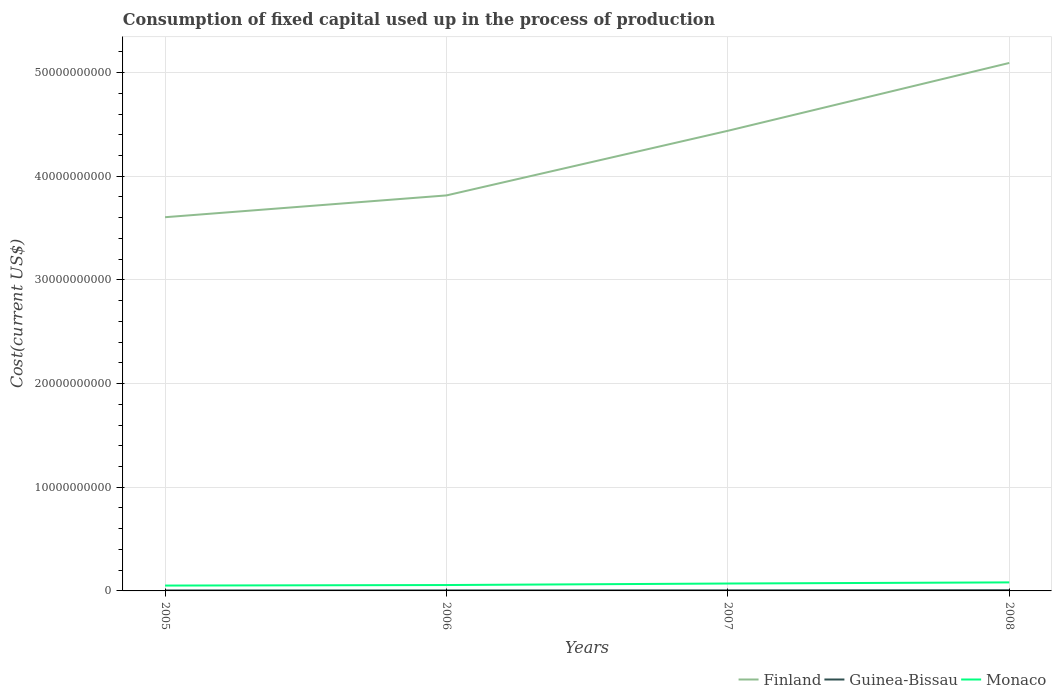Does the line corresponding to Finland intersect with the line corresponding to Monaco?
Give a very brief answer. No. Is the number of lines equal to the number of legend labels?
Provide a short and direct response. Yes. Across all years, what is the maximum amount consumed in the process of production in Finland?
Make the answer very short. 3.60e+1. In which year was the amount consumed in the process of production in Guinea-Bissau maximum?
Ensure brevity in your answer.  2005. What is the total amount consumed in the process of production in Monaco in the graph?
Ensure brevity in your answer.  -3.06e+08. What is the difference between the highest and the second highest amount consumed in the process of production in Monaco?
Offer a terse response. 3.06e+08. Is the amount consumed in the process of production in Monaco strictly greater than the amount consumed in the process of production in Finland over the years?
Your response must be concise. Yes. How many years are there in the graph?
Make the answer very short. 4. What is the difference between two consecutive major ticks on the Y-axis?
Provide a succinct answer. 1.00e+1. Are the values on the major ticks of Y-axis written in scientific E-notation?
Your answer should be very brief. No. Does the graph contain any zero values?
Offer a very short reply. No. How are the legend labels stacked?
Keep it short and to the point. Horizontal. What is the title of the graph?
Offer a terse response. Consumption of fixed capital used up in the process of production. What is the label or title of the Y-axis?
Offer a terse response. Cost(current US$). What is the Cost(current US$) of Finland in 2005?
Your answer should be very brief. 3.60e+1. What is the Cost(current US$) of Guinea-Bissau in 2005?
Your answer should be compact. 4.68e+07. What is the Cost(current US$) of Monaco in 2005?
Give a very brief answer. 5.16e+08. What is the Cost(current US$) in Finland in 2006?
Provide a short and direct response. 3.81e+1. What is the Cost(current US$) of Guinea-Bissau in 2006?
Make the answer very short. 4.78e+07. What is the Cost(current US$) in Monaco in 2006?
Your answer should be very brief. 5.68e+08. What is the Cost(current US$) of Finland in 2007?
Give a very brief answer. 4.44e+1. What is the Cost(current US$) in Guinea-Bissau in 2007?
Offer a very short reply. 5.62e+07. What is the Cost(current US$) in Monaco in 2007?
Your answer should be very brief. 7.14e+08. What is the Cost(current US$) of Finland in 2008?
Provide a short and direct response. 5.09e+1. What is the Cost(current US$) in Guinea-Bissau in 2008?
Provide a succinct answer. 6.96e+07. What is the Cost(current US$) of Monaco in 2008?
Your answer should be compact. 8.23e+08. Across all years, what is the maximum Cost(current US$) in Finland?
Provide a succinct answer. 5.09e+1. Across all years, what is the maximum Cost(current US$) of Guinea-Bissau?
Your response must be concise. 6.96e+07. Across all years, what is the maximum Cost(current US$) in Monaco?
Your answer should be very brief. 8.23e+08. Across all years, what is the minimum Cost(current US$) in Finland?
Your answer should be compact. 3.60e+1. Across all years, what is the minimum Cost(current US$) of Guinea-Bissau?
Provide a short and direct response. 4.68e+07. Across all years, what is the minimum Cost(current US$) in Monaco?
Your response must be concise. 5.16e+08. What is the total Cost(current US$) in Finland in the graph?
Your answer should be compact. 1.70e+11. What is the total Cost(current US$) of Guinea-Bissau in the graph?
Provide a succinct answer. 2.20e+08. What is the total Cost(current US$) in Monaco in the graph?
Provide a succinct answer. 2.62e+09. What is the difference between the Cost(current US$) of Finland in 2005 and that in 2006?
Offer a very short reply. -2.10e+09. What is the difference between the Cost(current US$) in Guinea-Bissau in 2005 and that in 2006?
Provide a succinct answer. -1.03e+06. What is the difference between the Cost(current US$) in Monaco in 2005 and that in 2006?
Your response must be concise. -5.15e+07. What is the difference between the Cost(current US$) in Finland in 2005 and that in 2007?
Ensure brevity in your answer.  -8.34e+09. What is the difference between the Cost(current US$) in Guinea-Bissau in 2005 and that in 2007?
Ensure brevity in your answer.  -9.36e+06. What is the difference between the Cost(current US$) in Monaco in 2005 and that in 2007?
Ensure brevity in your answer.  -1.98e+08. What is the difference between the Cost(current US$) of Finland in 2005 and that in 2008?
Keep it short and to the point. -1.49e+1. What is the difference between the Cost(current US$) in Guinea-Bissau in 2005 and that in 2008?
Offer a very short reply. -2.28e+07. What is the difference between the Cost(current US$) of Monaco in 2005 and that in 2008?
Your answer should be compact. -3.06e+08. What is the difference between the Cost(current US$) in Finland in 2006 and that in 2007?
Your answer should be compact. -6.23e+09. What is the difference between the Cost(current US$) in Guinea-Bissau in 2006 and that in 2007?
Your response must be concise. -8.33e+06. What is the difference between the Cost(current US$) in Monaco in 2006 and that in 2007?
Ensure brevity in your answer.  -1.47e+08. What is the difference between the Cost(current US$) of Finland in 2006 and that in 2008?
Offer a terse response. -1.28e+1. What is the difference between the Cost(current US$) in Guinea-Bissau in 2006 and that in 2008?
Give a very brief answer. -2.18e+07. What is the difference between the Cost(current US$) in Monaco in 2006 and that in 2008?
Keep it short and to the point. -2.55e+08. What is the difference between the Cost(current US$) of Finland in 2007 and that in 2008?
Offer a terse response. -6.54e+09. What is the difference between the Cost(current US$) of Guinea-Bissau in 2007 and that in 2008?
Your answer should be very brief. -1.35e+07. What is the difference between the Cost(current US$) in Monaco in 2007 and that in 2008?
Your response must be concise. -1.08e+08. What is the difference between the Cost(current US$) in Finland in 2005 and the Cost(current US$) in Guinea-Bissau in 2006?
Provide a succinct answer. 3.60e+1. What is the difference between the Cost(current US$) in Finland in 2005 and the Cost(current US$) in Monaco in 2006?
Provide a succinct answer. 3.55e+1. What is the difference between the Cost(current US$) of Guinea-Bissau in 2005 and the Cost(current US$) of Monaco in 2006?
Offer a terse response. -5.21e+08. What is the difference between the Cost(current US$) in Finland in 2005 and the Cost(current US$) in Guinea-Bissau in 2007?
Provide a succinct answer. 3.60e+1. What is the difference between the Cost(current US$) in Finland in 2005 and the Cost(current US$) in Monaco in 2007?
Offer a terse response. 3.53e+1. What is the difference between the Cost(current US$) in Guinea-Bissau in 2005 and the Cost(current US$) in Monaco in 2007?
Your answer should be compact. -6.68e+08. What is the difference between the Cost(current US$) of Finland in 2005 and the Cost(current US$) of Guinea-Bissau in 2008?
Your answer should be very brief. 3.60e+1. What is the difference between the Cost(current US$) of Finland in 2005 and the Cost(current US$) of Monaco in 2008?
Ensure brevity in your answer.  3.52e+1. What is the difference between the Cost(current US$) in Guinea-Bissau in 2005 and the Cost(current US$) in Monaco in 2008?
Ensure brevity in your answer.  -7.76e+08. What is the difference between the Cost(current US$) of Finland in 2006 and the Cost(current US$) of Guinea-Bissau in 2007?
Provide a short and direct response. 3.81e+1. What is the difference between the Cost(current US$) in Finland in 2006 and the Cost(current US$) in Monaco in 2007?
Give a very brief answer. 3.74e+1. What is the difference between the Cost(current US$) in Guinea-Bissau in 2006 and the Cost(current US$) in Monaco in 2007?
Offer a terse response. -6.67e+08. What is the difference between the Cost(current US$) of Finland in 2006 and the Cost(current US$) of Guinea-Bissau in 2008?
Offer a terse response. 3.81e+1. What is the difference between the Cost(current US$) of Finland in 2006 and the Cost(current US$) of Monaco in 2008?
Provide a succinct answer. 3.73e+1. What is the difference between the Cost(current US$) of Guinea-Bissau in 2006 and the Cost(current US$) of Monaco in 2008?
Ensure brevity in your answer.  -7.75e+08. What is the difference between the Cost(current US$) in Finland in 2007 and the Cost(current US$) in Guinea-Bissau in 2008?
Keep it short and to the point. 4.43e+1. What is the difference between the Cost(current US$) of Finland in 2007 and the Cost(current US$) of Monaco in 2008?
Offer a very short reply. 4.36e+1. What is the difference between the Cost(current US$) in Guinea-Bissau in 2007 and the Cost(current US$) in Monaco in 2008?
Offer a very short reply. -7.66e+08. What is the average Cost(current US$) in Finland per year?
Make the answer very short. 4.24e+1. What is the average Cost(current US$) of Guinea-Bissau per year?
Give a very brief answer. 5.51e+07. What is the average Cost(current US$) in Monaco per year?
Your response must be concise. 6.55e+08. In the year 2005, what is the difference between the Cost(current US$) in Finland and Cost(current US$) in Guinea-Bissau?
Keep it short and to the point. 3.60e+1. In the year 2005, what is the difference between the Cost(current US$) of Finland and Cost(current US$) of Monaco?
Offer a very short reply. 3.55e+1. In the year 2005, what is the difference between the Cost(current US$) of Guinea-Bissau and Cost(current US$) of Monaco?
Offer a very short reply. -4.69e+08. In the year 2006, what is the difference between the Cost(current US$) in Finland and Cost(current US$) in Guinea-Bissau?
Your answer should be very brief. 3.81e+1. In the year 2006, what is the difference between the Cost(current US$) of Finland and Cost(current US$) of Monaco?
Keep it short and to the point. 3.76e+1. In the year 2006, what is the difference between the Cost(current US$) of Guinea-Bissau and Cost(current US$) of Monaco?
Keep it short and to the point. -5.20e+08. In the year 2007, what is the difference between the Cost(current US$) of Finland and Cost(current US$) of Guinea-Bissau?
Offer a very short reply. 4.43e+1. In the year 2007, what is the difference between the Cost(current US$) in Finland and Cost(current US$) in Monaco?
Give a very brief answer. 4.37e+1. In the year 2007, what is the difference between the Cost(current US$) of Guinea-Bissau and Cost(current US$) of Monaco?
Offer a terse response. -6.58e+08. In the year 2008, what is the difference between the Cost(current US$) of Finland and Cost(current US$) of Guinea-Bissau?
Keep it short and to the point. 5.09e+1. In the year 2008, what is the difference between the Cost(current US$) of Finland and Cost(current US$) of Monaco?
Make the answer very short. 5.01e+1. In the year 2008, what is the difference between the Cost(current US$) of Guinea-Bissau and Cost(current US$) of Monaco?
Your answer should be very brief. -7.53e+08. What is the ratio of the Cost(current US$) of Finland in 2005 to that in 2006?
Keep it short and to the point. 0.94. What is the ratio of the Cost(current US$) in Guinea-Bissau in 2005 to that in 2006?
Provide a short and direct response. 0.98. What is the ratio of the Cost(current US$) of Monaco in 2005 to that in 2006?
Provide a succinct answer. 0.91. What is the ratio of the Cost(current US$) of Finland in 2005 to that in 2007?
Ensure brevity in your answer.  0.81. What is the ratio of the Cost(current US$) of Guinea-Bissau in 2005 to that in 2007?
Ensure brevity in your answer.  0.83. What is the ratio of the Cost(current US$) in Monaco in 2005 to that in 2007?
Provide a short and direct response. 0.72. What is the ratio of the Cost(current US$) in Finland in 2005 to that in 2008?
Your response must be concise. 0.71. What is the ratio of the Cost(current US$) in Guinea-Bissau in 2005 to that in 2008?
Your answer should be compact. 0.67. What is the ratio of the Cost(current US$) of Monaco in 2005 to that in 2008?
Your answer should be compact. 0.63. What is the ratio of the Cost(current US$) of Finland in 2006 to that in 2007?
Your response must be concise. 0.86. What is the ratio of the Cost(current US$) of Guinea-Bissau in 2006 to that in 2007?
Give a very brief answer. 0.85. What is the ratio of the Cost(current US$) of Monaco in 2006 to that in 2007?
Provide a short and direct response. 0.79. What is the ratio of the Cost(current US$) of Finland in 2006 to that in 2008?
Your response must be concise. 0.75. What is the ratio of the Cost(current US$) of Guinea-Bissau in 2006 to that in 2008?
Your answer should be very brief. 0.69. What is the ratio of the Cost(current US$) in Monaco in 2006 to that in 2008?
Offer a terse response. 0.69. What is the ratio of the Cost(current US$) of Finland in 2007 to that in 2008?
Make the answer very short. 0.87. What is the ratio of the Cost(current US$) in Guinea-Bissau in 2007 to that in 2008?
Offer a very short reply. 0.81. What is the ratio of the Cost(current US$) of Monaco in 2007 to that in 2008?
Keep it short and to the point. 0.87. What is the difference between the highest and the second highest Cost(current US$) of Finland?
Give a very brief answer. 6.54e+09. What is the difference between the highest and the second highest Cost(current US$) in Guinea-Bissau?
Your answer should be very brief. 1.35e+07. What is the difference between the highest and the second highest Cost(current US$) of Monaco?
Provide a succinct answer. 1.08e+08. What is the difference between the highest and the lowest Cost(current US$) of Finland?
Your response must be concise. 1.49e+1. What is the difference between the highest and the lowest Cost(current US$) of Guinea-Bissau?
Your answer should be very brief. 2.28e+07. What is the difference between the highest and the lowest Cost(current US$) in Monaco?
Ensure brevity in your answer.  3.06e+08. 